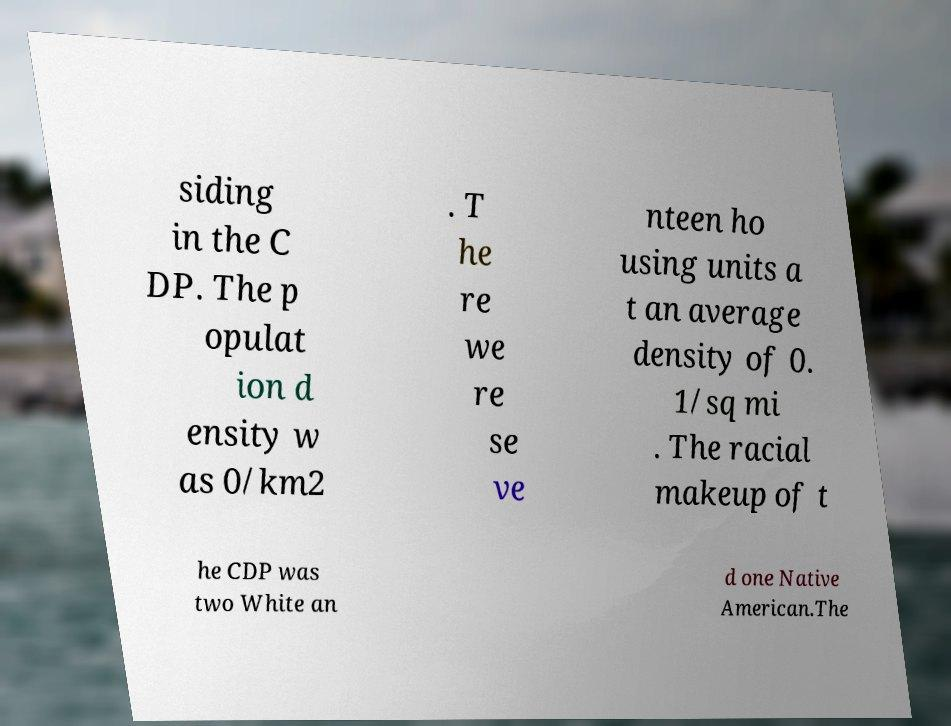For documentation purposes, I need the text within this image transcribed. Could you provide that? siding in the C DP. The p opulat ion d ensity w as 0/km2 . T he re we re se ve nteen ho using units a t an average density of 0. 1/sq mi . The racial makeup of t he CDP was two White an d one Native American.The 